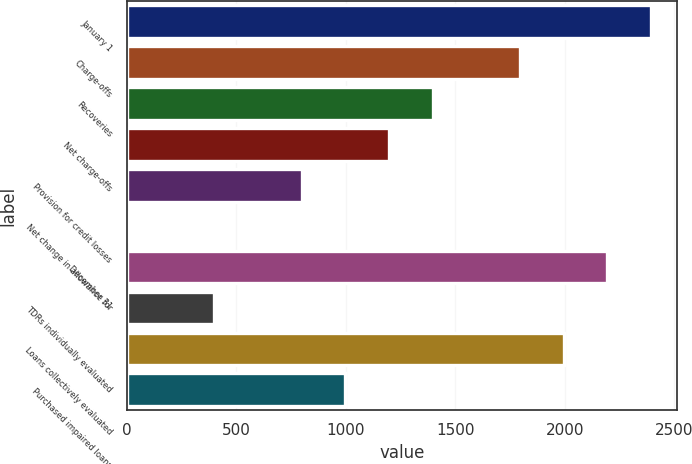Convert chart. <chart><loc_0><loc_0><loc_500><loc_500><bar_chart><fcel>January 1<fcel>Charge-offs<fcel>Recoveries<fcel>Net charge-offs<fcel>Provision for credit losses<fcel>Net change in allowance for<fcel>December 31<fcel>TDRs individually evaluated<fcel>Loans collectively evaluated<fcel>Purchased impaired loans<nl><fcel>2393.8<fcel>1795.6<fcel>1396.8<fcel>1197.4<fcel>798.6<fcel>1<fcel>2194.4<fcel>399.8<fcel>1995<fcel>998<nl></chart> 